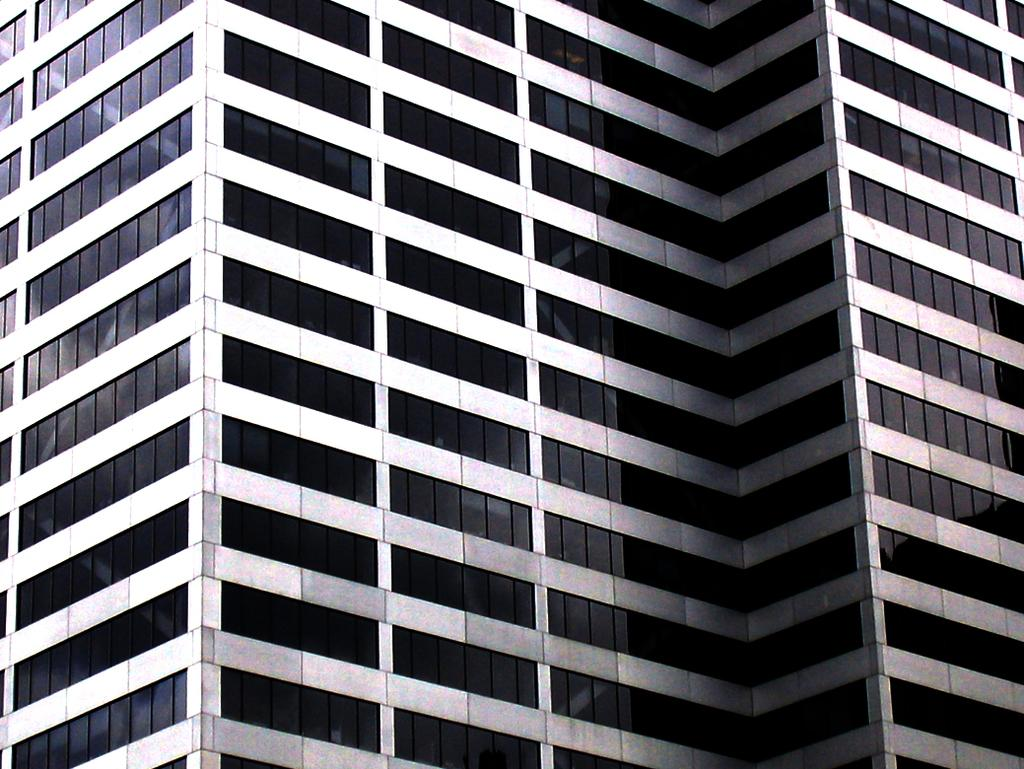What type of structure is visible in the image? There is a building in the image. What type of cave can be seen behind the building in the image? There is no cave present in the image; it only features a building. What is the back of the building made of in the image? The back of the building is not visible in the image, so it cannot be determined what it is made of. 